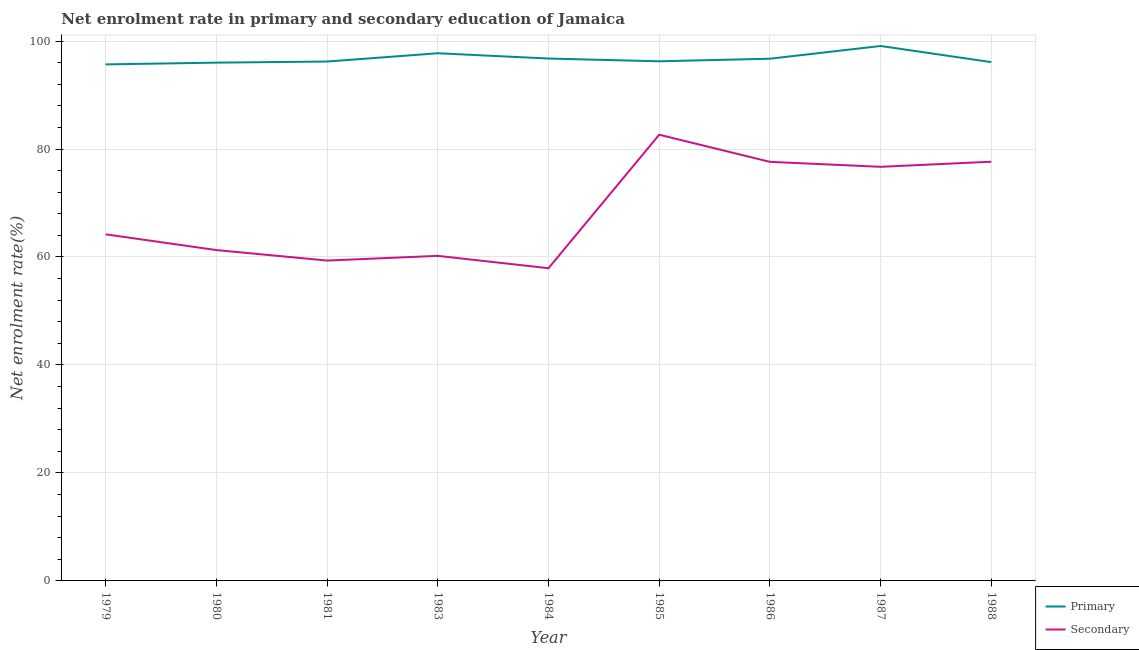How many different coloured lines are there?
Offer a very short reply. 2. What is the enrollment rate in primary education in 1979?
Provide a short and direct response. 95.67. Across all years, what is the maximum enrollment rate in secondary education?
Offer a very short reply. 82.65. Across all years, what is the minimum enrollment rate in primary education?
Keep it short and to the point. 95.67. In which year was the enrollment rate in primary education maximum?
Your answer should be very brief. 1987. In which year was the enrollment rate in primary education minimum?
Ensure brevity in your answer.  1979. What is the total enrollment rate in secondary education in the graph?
Your answer should be very brief. 617.58. What is the difference between the enrollment rate in primary education in 1985 and that in 1986?
Your answer should be compact. -0.48. What is the difference between the enrollment rate in secondary education in 1980 and the enrollment rate in primary education in 1988?
Offer a terse response. -34.81. What is the average enrollment rate in secondary education per year?
Give a very brief answer. 68.62. In the year 1987, what is the difference between the enrollment rate in secondary education and enrollment rate in primary education?
Make the answer very short. -22.38. What is the ratio of the enrollment rate in secondary education in 1981 to that in 1986?
Your answer should be very brief. 0.76. What is the difference between the highest and the second highest enrollment rate in secondary education?
Keep it short and to the point. 5. What is the difference between the highest and the lowest enrollment rate in primary education?
Provide a short and direct response. 3.41. Is the sum of the enrollment rate in secondary education in 1983 and 1985 greater than the maximum enrollment rate in primary education across all years?
Give a very brief answer. Yes. Is the enrollment rate in secondary education strictly less than the enrollment rate in primary education over the years?
Provide a short and direct response. Yes. What is the difference between two consecutive major ticks on the Y-axis?
Your answer should be very brief. 20. Does the graph contain grids?
Your response must be concise. Yes. Where does the legend appear in the graph?
Give a very brief answer. Bottom right. What is the title of the graph?
Provide a succinct answer. Net enrolment rate in primary and secondary education of Jamaica. Does "Largest city" appear as one of the legend labels in the graph?
Provide a short and direct response. No. What is the label or title of the Y-axis?
Ensure brevity in your answer.  Net enrolment rate(%). What is the Net enrolment rate(%) in Primary in 1979?
Ensure brevity in your answer.  95.67. What is the Net enrolment rate(%) in Secondary in 1979?
Provide a short and direct response. 64.2. What is the Net enrolment rate(%) in Primary in 1980?
Offer a terse response. 96. What is the Net enrolment rate(%) of Secondary in 1980?
Offer a terse response. 61.28. What is the Net enrolment rate(%) in Primary in 1981?
Your answer should be compact. 96.2. What is the Net enrolment rate(%) of Secondary in 1981?
Your response must be concise. 59.34. What is the Net enrolment rate(%) in Primary in 1983?
Your answer should be very brief. 97.74. What is the Net enrolment rate(%) in Secondary in 1983?
Your answer should be very brief. 60.21. What is the Net enrolment rate(%) of Primary in 1984?
Your answer should be very brief. 96.76. What is the Net enrolment rate(%) of Secondary in 1984?
Provide a succinct answer. 57.92. What is the Net enrolment rate(%) in Primary in 1985?
Offer a very short reply. 96.25. What is the Net enrolment rate(%) of Secondary in 1985?
Keep it short and to the point. 82.65. What is the Net enrolment rate(%) of Primary in 1986?
Offer a terse response. 96.73. What is the Net enrolment rate(%) of Secondary in 1986?
Your answer should be very brief. 77.62. What is the Net enrolment rate(%) in Primary in 1987?
Make the answer very short. 99.08. What is the Net enrolment rate(%) in Secondary in 1987?
Your answer should be compact. 76.7. What is the Net enrolment rate(%) in Primary in 1988?
Provide a succinct answer. 96.09. What is the Net enrolment rate(%) in Secondary in 1988?
Ensure brevity in your answer.  77.65. Across all years, what is the maximum Net enrolment rate(%) of Primary?
Make the answer very short. 99.08. Across all years, what is the maximum Net enrolment rate(%) of Secondary?
Your response must be concise. 82.65. Across all years, what is the minimum Net enrolment rate(%) of Primary?
Make the answer very short. 95.67. Across all years, what is the minimum Net enrolment rate(%) in Secondary?
Make the answer very short. 57.92. What is the total Net enrolment rate(%) in Primary in the graph?
Your answer should be very brief. 870.53. What is the total Net enrolment rate(%) of Secondary in the graph?
Provide a short and direct response. 617.58. What is the difference between the Net enrolment rate(%) in Primary in 1979 and that in 1980?
Give a very brief answer. -0.32. What is the difference between the Net enrolment rate(%) in Secondary in 1979 and that in 1980?
Offer a terse response. 2.91. What is the difference between the Net enrolment rate(%) of Primary in 1979 and that in 1981?
Provide a short and direct response. -0.53. What is the difference between the Net enrolment rate(%) in Secondary in 1979 and that in 1981?
Keep it short and to the point. 4.86. What is the difference between the Net enrolment rate(%) in Primary in 1979 and that in 1983?
Provide a short and direct response. -2.07. What is the difference between the Net enrolment rate(%) in Secondary in 1979 and that in 1983?
Your response must be concise. 3.99. What is the difference between the Net enrolment rate(%) of Primary in 1979 and that in 1984?
Offer a very short reply. -1.09. What is the difference between the Net enrolment rate(%) in Secondary in 1979 and that in 1984?
Provide a short and direct response. 6.28. What is the difference between the Net enrolment rate(%) in Primary in 1979 and that in 1985?
Your response must be concise. -0.57. What is the difference between the Net enrolment rate(%) in Secondary in 1979 and that in 1985?
Your answer should be very brief. -18.45. What is the difference between the Net enrolment rate(%) in Primary in 1979 and that in 1986?
Offer a terse response. -1.05. What is the difference between the Net enrolment rate(%) in Secondary in 1979 and that in 1986?
Offer a very short reply. -13.43. What is the difference between the Net enrolment rate(%) of Primary in 1979 and that in 1987?
Ensure brevity in your answer.  -3.41. What is the difference between the Net enrolment rate(%) in Secondary in 1979 and that in 1987?
Your response must be concise. -12.51. What is the difference between the Net enrolment rate(%) in Primary in 1979 and that in 1988?
Your answer should be very brief. -0.42. What is the difference between the Net enrolment rate(%) in Secondary in 1979 and that in 1988?
Ensure brevity in your answer.  -13.45. What is the difference between the Net enrolment rate(%) in Primary in 1980 and that in 1981?
Give a very brief answer. -0.21. What is the difference between the Net enrolment rate(%) in Secondary in 1980 and that in 1981?
Your response must be concise. 1.94. What is the difference between the Net enrolment rate(%) in Primary in 1980 and that in 1983?
Your answer should be compact. -1.74. What is the difference between the Net enrolment rate(%) in Secondary in 1980 and that in 1983?
Give a very brief answer. 1.07. What is the difference between the Net enrolment rate(%) in Primary in 1980 and that in 1984?
Your response must be concise. -0.76. What is the difference between the Net enrolment rate(%) in Secondary in 1980 and that in 1984?
Make the answer very short. 3.36. What is the difference between the Net enrolment rate(%) of Primary in 1980 and that in 1985?
Offer a terse response. -0.25. What is the difference between the Net enrolment rate(%) in Secondary in 1980 and that in 1985?
Your answer should be very brief. -21.36. What is the difference between the Net enrolment rate(%) of Primary in 1980 and that in 1986?
Your answer should be very brief. -0.73. What is the difference between the Net enrolment rate(%) in Secondary in 1980 and that in 1986?
Your response must be concise. -16.34. What is the difference between the Net enrolment rate(%) of Primary in 1980 and that in 1987?
Keep it short and to the point. -3.09. What is the difference between the Net enrolment rate(%) in Secondary in 1980 and that in 1987?
Your answer should be compact. -15.42. What is the difference between the Net enrolment rate(%) in Primary in 1980 and that in 1988?
Offer a very short reply. -0.1. What is the difference between the Net enrolment rate(%) in Secondary in 1980 and that in 1988?
Provide a succinct answer. -16.37. What is the difference between the Net enrolment rate(%) of Primary in 1981 and that in 1983?
Give a very brief answer. -1.54. What is the difference between the Net enrolment rate(%) of Secondary in 1981 and that in 1983?
Your answer should be very brief. -0.87. What is the difference between the Net enrolment rate(%) in Primary in 1981 and that in 1984?
Offer a terse response. -0.56. What is the difference between the Net enrolment rate(%) of Secondary in 1981 and that in 1984?
Give a very brief answer. 1.42. What is the difference between the Net enrolment rate(%) in Primary in 1981 and that in 1985?
Offer a very short reply. -0.05. What is the difference between the Net enrolment rate(%) of Secondary in 1981 and that in 1985?
Provide a succinct answer. -23.31. What is the difference between the Net enrolment rate(%) in Primary in 1981 and that in 1986?
Your answer should be compact. -0.52. What is the difference between the Net enrolment rate(%) of Secondary in 1981 and that in 1986?
Offer a very short reply. -18.28. What is the difference between the Net enrolment rate(%) in Primary in 1981 and that in 1987?
Provide a short and direct response. -2.88. What is the difference between the Net enrolment rate(%) in Secondary in 1981 and that in 1987?
Provide a short and direct response. -17.36. What is the difference between the Net enrolment rate(%) of Primary in 1981 and that in 1988?
Offer a very short reply. 0.11. What is the difference between the Net enrolment rate(%) in Secondary in 1981 and that in 1988?
Ensure brevity in your answer.  -18.31. What is the difference between the Net enrolment rate(%) in Primary in 1983 and that in 1984?
Ensure brevity in your answer.  0.98. What is the difference between the Net enrolment rate(%) in Secondary in 1983 and that in 1984?
Your answer should be compact. 2.29. What is the difference between the Net enrolment rate(%) of Primary in 1983 and that in 1985?
Ensure brevity in your answer.  1.49. What is the difference between the Net enrolment rate(%) of Secondary in 1983 and that in 1985?
Your answer should be compact. -22.44. What is the difference between the Net enrolment rate(%) in Primary in 1983 and that in 1986?
Give a very brief answer. 1.01. What is the difference between the Net enrolment rate(%) of Secondary in 1983 and that in 1986?
Keep it short and to the point. -17.41. What is the difference between the Net enrolment rate(%) in Primary in 1983 and that in 1987?
Provide a short and direct response. -1.34. What is the difference between the Net enrolment rate(%) of Secondary in 1983 and that in 1987?
Your answer should be very brief. -16.49. What is the difference between the Net enrolment rate(%) in Primary in 1983 and that in 1988?
Provide a succinct answer. 1.64. What is the difference between the Net enrolment rate(%) of Secondary in 1983 and that in 1988?
Give a very brief answer. -17.44. What is the difference between the Net enrolment rate(%) in Primary in 1984 and that in 1985?
Offer a terse response. 0.51. What is the difference between the Net enrolment rate(%) in Secondary in 1984 and that in 1985?
Make the answer very short. -24.72. What is the difference between the Net enrolment rate(%) in Primary in 1984 and that in 1986?
Your response must be concise. 0.03. What is the difference between the Net enrolment rate(%) of Secondary in 1984 and that in 1986?
Offer a terse response. -19.7. What is the difference between the Net enrolment rate(%) in Primary in 1984 and that in 1987?
Offer a terse response. -2.32. What is the difference between the Net enrolment rate(%) of Secondary in 1984 and that in 1987?
Keep it short and to the point. -18.78. What is the difference between the Net enrolment rate(%) of Primary in 1984 and that in 1988?
Your response must be concise. 0.67. What is the difference between the Net enrolment rate(%) in Secondary in 1984 and that in 1988?
Provide a succinct answer. -19.73. What is the difference between the Net enrolment rate(%) in Primary in 1985 and that in 1986?
Make the answer very short. -0.48. What is the difference between the Net enrolment rate(%) in Secondary in 1985 and that in 1986?
Keep it short and to the point. 5.02. What is the difference between the Net enrolment rate(%) in Primary in 1985 and that in 1987?
Your answer should be compact. -2.83. What is the difference between the Net enrolment rate(%) in Secondary in 1985 and that in 1987?
Your response must be concise. 5.94. What is the difference between the Net enrolment rate(%) of Primary in 1985 and that in 1988?
Your answer should be very brief. 0.15. What is the difference between the Net enrolment rate(%) of Secondary in 1985 and that in 1988?
Ensure brevity in your answer.  5. What is the difference between the Net enrolment rate(%) of Primary in 1986 and that in 1987?
Keep it short and to the point. -2.36. What is the difference between the Net enrolment rate(%) in Secondary in 1986 and that in 1987?
Offer a terse response. 0.92. What is the difference between the Net enrolment rate(%) of Primary in 1986 and that in 1988?
Offer a very short reply. 0.63. What is the difference between the Net enrolment rate(%) in Secondary in 1986 and that in 1988?
Give a very brief answer. -0.03. What is the difference between the Net enrolment rate(%) in Primary in 1987 and that in 1988?
Ensure brevity in your answer.  2.99. What is the difference between the Net enrolment rate(%) of Secondary in 1987 and that in 1988?
Your answer should be compact. -0.95. What is the difference between the Net enrolment rate(%) of Primary in 1979 and the Net enrolment rate(%) of Secondary in 1980?
Ensure brevity in your answer.  34.39. What is the difference between the Net enrolment rate(%) of Primary in 1979 and the Net enrolment rate(%) of Secondary in 1981?
Your answer should be compact. 36.33. What is the difference between the Net enrolment rate(%) in Primary in 1979 and the Net enrolment rate(%) in Secondary in 1983?
Provide a short and direct response. 35.46. What is the difference between the Net enrolment rate(%) of Primary in 1979 and the Net enrolment rate(%) of Secondary in 1984?
Offer a terse response. 37.75. What is the difference between the Net enrolment rate(%) of Primary in 1979 and the Net enrolment rate(%) of Secondary in 1985?
Ensure brevity in your answer.  13.03. What is the difference between the Net enrolment rate(%) of Primary in 1979 and the Net enrolment rate(%) of Secondary in 1986?
Ensure brevity in your answer.  18.05. What is the difference between the Net enrolment rate(%) in Primary in 1979 and the Net enrolment rate(%) in Secondary in 1987?
Provide a short and direct response. 18.97. What is the difference between the Net enrolment rate(%) of Primary in 1979 and the Net enrolment rate(%) of Secondary in 1988?
Your response must be concise. 18.02. What is the difference between the Net enrolment rate(%) of Primary in 1980 and the Net enrolment rate(%) of Secondary in 1981?
Give a very brief answer. 36.66. What is the difference between the Net enrolment rate(%) in Primary in 1980 and the Net enrolment rate(%) in Secondary in 1983?
Give a very brief answer. 35.79. What is the difference between the Net enrolment rate(%) in Primary in 1980 and the Net enrolment rate(%) in Secondary in 1984?
Provide a short and direct response. 38.08. What is the difference between the Net enrolment rate(%) in Primary in 1980 and the Net enrolment rate(%) in Secondary in 1985?
Your answer should be compact. 13.35. What is the difference between the Net enrolment rate(%) of Primary in 1980 and the Net enrolment rate(%) of Secondary in 1986?
Offer a very short reply. 18.37. What is the difference between the Net enrolment rate(%) of Primary in 1980 and the Net enrolment rate(%) of Secondary in 1987?
Offer a very short reply. 19.29. What is the difference between the Net enrolment rate(%) of Primary in 1980 and the Net enrolment rate(%) of Secondary in 1988?
Offer a very short reply. 18.35. What is the difference between the Net enrolment rate(%) in Primary in 1981 and the Net enrolment rate(%) in Secondary in 1983?
Give a very brief answer. 35.99. What is the difference between the Net enrolment rate(%) in Primary in 1981 and the Net enrolment rate(%) in Secondary in 1984?
Your answer should be compact. 38.28. What is the difference between the Net enrolment rate(%) in Primary in 1981 and the Net enrolment rate(%) in Secondary in 1985?
Ensure brevity in your answer.  13.56. What is the difference between the Net enrolment rate(%) of Primary in 1981 and the Net enrolment rate(%) of Secondary in 1986?
Provide a short and direct response. 18.58. What is the difference between the Net enrolment rate(%) in Primary in 1981 and the Net enrolment rate(%) in Secondary in 1987?
Offer a very short reply. 19.5. What is the difference between the Net enrolment rate(%) of Primary in 1981 and the Net enrolment rate(%) of Secondary in 1988?
Your answer should be very brief. 18.55. What is the difference between the Net enrolment rate(%) in Primary in 1983 and the Net enrolment rate(%) in Secondary in 1984?
Your answer should be compact. 39.82. What is the difference between the Net enrolment rate(%) in Primary in 1983 and the Net enrolment rate(%) in Secondary in 1985?
Ensure brevity in your answer.  15.09. What is the difference between the Net enrolment rate(%) of Primary in 1983 and the Net enrolment rate(%) of Secondary in 1986?
Provide a succinct answer. 20.12. What is the difference between the Net enrolment rate(%) in Primary in 1983 and the Net enrolment rate(%) in Secondary in 1987?
Ensure brevity in your answer.  21.04. What is the difference between the Net enrolment rate(%) of Primary in 1983 and the Net enrolment rate(%) of Secondary in 1988?
Keep it short and to the point. 20.09. What is the difference between the Net enrolment rate(%) in Primary in 1984 and the Net enrolment rate(%) in Secondary in 1985?
Your answer should be very brief. 14.11. What is the difference between the Net enrolment rate(%) of Primary in 1984 and the Net enrolment rate(%) of Secondary in 1986?
Your response must be concise. 19.14. What is the difference between the Net enrolment rate(%) of Primary in 1984 and the Net enrolment rate(%) of Secondary in 1987?
Provide a short and direct response. 20.06. What is the difference between the Net enrolment rate(%) of Primary in 1984 and the Net enrolment rate(%) of Secondary in 1988?
Give a very brief answer. 19.11. What is the difference between the Net enrolment rate(%) of Primary in 1985 and the Net enrolment rate(%) of Secondary in 1986?
Offer a very short reply. 18.63. What is the difference between the Net enrolment rate(%) of Primary in 1985 and the Net enrolment rate(%) of Secondary in 1987?
Your answer should be compact. 19.55. What is the difference between the Net enrolment rate(%) in Primary in 1985 and the Net enrolment rate(%) in Secondary in 1988?
Your response must be concise. 18.6. What is the difference between the Net enrolment rate(%) in Primary in 1986 and the Net enrolment rate(%) in Secondary in 1987?
Provide a short and direct response. 20.02. What is the difference between the Net enrolment rate(%) in Primary in 1986 and the Net enrolment rate(%) in Secondary in 1988?
Your answer should be very brief. 19.08. What is the difference between the Net enrolment rate(%) of Primary in 1987 and the Net enrolment rate(%) of Secondary in 1988?
Offer a terse response. 21.43. What is the average Net enrolment rate(%) of Primary per year?
Give a very brief answer. 96.73. What is the average Net enrolment rate(%) in Secondary per year?
Ensure brevity in your answer.  68.62. In the year 1979, what is the difference between the Net enrolment rate(%) of Primary and Net enrolment rate(%) of Secondary?
Offer a very short reply. 31.48. In the year 1980, what is the difference between the Net enrolment rate(%) of Primary and Net enrolment rate(%) of Secondary?
Your response must be concise. 34.71. In the year 1981, what is the difference between the Net enrolment rate(%) in Primary and Net enrolment rate(%) in Secondary?
Provide a short and direct response. 36.86. In the year 1983, what is the difference between the Net enrolment rate(%) of Primary and Net enrolment rate(%) of Secondary?
Keep it short and to the point. 37.53. In the year 1984, what is the difference between the Net enrolment rate(%) of Primary and Net enrolment rate(%) of Secondary?
Provide a short and direct response. 38.84. In the year 1985, what is the difference between the Net enrolment rate(%) of Primary and Net enrolment rate(%) of Secondary?
Ensure brevity in your answer.  13.6. In the year 1986, what is the difference between the Net enrolment rate(%) in Primary and Net enrolment rate(%) in Secondary?
Offer a very short reply. 19.1. In the year 1987, what is the difference between the Net enrolment rate(%) in Primary and Net enrolment rate(%) in Secondary?
Ensure brevity in your answer.  22.38. In the year 1988, what is the difference between the Net enrolment rate(%) in Primary and Net enrolment rate(%) in Secondary?
Make the answer very short. 18.44. What is the ratio of the Net enrolment rate(%) of Primary in 1979 to that in 1980?
Ensure brevity in your answer.  1. What is the ratio of the Net enrolment rate(%) of Secondary in 1979 to that in 1980?
Ensure brevity in your answer.  1.05. What is the ratio of the Net enrolment rate(%) in Primary in 1979 to that in 1981?
Make the answer very short. 0.99. What is the ratio of the Net enrolment rate(%) of Secondary in 1979 to that in 1981?
Your answer should be compact. 1.08. What is the ratio of the Net enrolment rate(%) of Primary in 1979 to that in 1983?
Keep it short and to the point. 0.98. What is the ratio of the Net enrolment rate(%) in Secondary in 1979 to that in 1983?
Give a very brief answer. 1.07. What is the ratio of the Net enrolment rate(%) in Secondary in 1979 to that in 1984?
Your response must be concise. 1.11. What is the ratio of the Net enrolment rate(%) of Secondary in 1979 to that in 1985?
Provide a succinct answer. 0.78. What is the ratio of the Net enrolment rate(%) of Primary in 1979 to that in 1986?
Offer a very short reply. 0.99. What is the ratio of the Net enrolment rate(%) in Secondary in 1979 to that in 1986?
Give a very brief answer. 0.83. What is the ratio of the Net enrolment rate(%) of Primary in 1979 to that in 1987?
Ensure brevity in your answer.  0.97. What is the ratio of the Net enrolment rate(%) of Secondary in 1979 to that in 1987?
Offer a very short reply. 0.84. What is the ratio of the Net enrolment rate(%) of Primary in 1979 to that in 1988?
Your answer should be very brief. 1. What is the ratio of the Net enrolment rate(%) of Secondary in 1979 to that in 1988?
Your answer should be very brief. 0.83. What is the ratio of the Net enrolment rate(%) of Primary in 1980 to that in 1981?
Offer a very short reply. 1. What is the ratio of the Net enrolment rate(%) in Secondary in 1980 to that in 1981?
Keep it short and to the point. 1.03. What is the ratio of the Net enrolment rate(%) in Primary in 1980 to that in 1983?
Provide a short and direct response. 0.98. What is the ratio of the Net enrolment rate(%) in Secondary in 1980 to that in 1983?
Give a very brief answer. 1.02. What is the ratio of the Net enrolment rate(%) of Primary in 1980 to that in 1984?
Your answer should be compact. 0.99. What is the ratio of the Net enrolment rate(%) of Secondary in 1980 to that in 1984?
Ensure brevity in your answer.  1.06. What is the ratio of the Net enrolment rate(%) of Secondary in 1980 to that in 1985?
Offer a very short reply. 0.74. What is the ratio of the Net enrolment rate(%) in Secondary in 1980 to that in 1986?
Offer a terse response. 0.79. What is the ratio of the Net enrolment rate(%) of Primary in 1980 to that in 1987?
Offer a terse response. 0.97. What is the ratio of the Net enrolment rate(%) of Secondary in 1980 to that in 1987?
Your answer should be very brief. 0.8. What is the ratio of the Net enrolment rate(%) of Primary in 1980 to that in 1988?
Ensure brevity in your answer.  1. What is the ratio of the Net enrolment rate(%) of Secondary in 1980 to that in 1988?
Ensure brevity in your answer.  0.79. What is the ratio of the Net enrolment rate(%) of Primary in 1981 to that in 1983?
Your response must be concise. 0.98. What is the ratio of the Net enrolment rate(%) in Secondary in 1981 to that in 1983?
Give a very brief answer. 0.99. What is the ratio of the Net enrolment rate(%) of Secondary in 1981 to that in 1984?
Keep it short and to the point. 1.02. What is the ratio of the Net enrolment rate(%) in Secondary in 1981 to that in 1985?
Your response must be concise. 0.72. What is the ratio of the Net enrolment rate(%) of Secondary in 1981 to that in 1986?
Provide a succinct answer. 0.76. What is the ratio of the Net enrolment rate(%) of Primary in 1981 to that in 1987?
Give a very brief answer. 0.97. What is the ratio of the Net enrolment rate(%) in Secondary in 1981 to that in 1987?
Give a very brief answer. 0.77. What is the ratio of the Net enrolment rate(%) of Primary in 1981 to that in 1988?
Offer a very short reply. 1. What is the ratio of the Net enrolment rate(%) in Secondary in 1981 to that in 1988?
Provide a succinct answer. 0.76. What is the ratio of the Net enrolment rate(%) in Secondary in 1983 to that in 1984?
Offer a terse response. 1.04. What is the ratio of the Net enrolment rate(%) in Primary in 1983 to that in 1985?
Offer a very short reply. 1.02. What is the ratio of the Net enrolment rate(%) of Secondary in 1983 to that in 1985?
Provide a succinct answer. 0.73. What is the ratio of the Net enrolment rate(%) in Primary in 1983 to that in 1986?
Offer a terse response. 1.01. What is the ratio of the Net enrolment rate(%) of Secondary in 1983 to that in 1986?
Your answer should be compact. 0.78. What is the ratio of the Net enrolment rate(%) of Primary in 1983 to that in 1987?
Your response must be concise. 0.99. What is the ratio of the Net enrolment rate(%) in Secondary in 1983 to that in 1987?
Make the answer very short. 0.79. What is the ratio of the Net enrolment rate(%) in Primary in 1983 to that in 1988?
Your answer should be compact. 1.02. What is the ratio of the Net enrolment rate(%) in Secondary in 1983 to that in 1988?
Your response must be concise. 0.78. What is the ratio of the Net enrolment rate(%) of Secondary in 1984 to that in 1985?
Provide a short and direct response. 0.7. What is the ratio of the Net enrolment rate(%) of Primary in 1984 to that in 1986?
Keep it short and to the point. 1. What is the ratio of the Net enrolment rate(%) in Secondary in 1984 to that in 1986?
Make the answer very short. 0.75. What is the ratio of the Net enrolment rate(%) in Primary in 1984 to that in 1987?
Keep it short and to the point. 0.98. What is the ratio of the Net enrolment rate(%) of Secondary in 1984 to that in 1987?
Make the answer very short. 0.76. What is the ratio of the Net enrolment rate(%) in Secondary in 1984 to that in 1988?
Provide a succinct answer. 0.75. What is the ratio of the Net enrolment rate(%) in Secondary in 1985 to that in 1986?
Provide a short and direct response. 1.06. What is the ratio of the Net enrolment rate(%) of Primary in 1985 to that in 1987?
Offer a terse response. 0.97. What is the ratio of the Net enrolment rate(%) in Secondary in 1985 to that in 1987?
Your answer should be very brief. 1.08. What is the ratio of the Net enrolment rate(%) of Secondary in 1985 to that in 1988?
Ensure brevity in your answer.  1.06. What is the ratio of the Net enrolment rate(%) in Primary in 1986 to that in 1987?
Offer a very short reply. 0.98. What is the ratio of the Net enrolment rate(%) of Secondary in 1986 to that in 1987?
Your response must be concise. 1.01. What is the ratio of the Net enrolment rate(%) in Primary in 1986 to that in 1988?
Make the answer very short. 1.01. What is the ratio of the Net enrolment rate(%) of Primary in 1987 to that in 1988?
Provide a succinct answer. 1.03. What is the ratio of the Net enrolment rate(%) of Secondary in 1987 to that in 1988?
Your answer should be compact. 0.99. What is the difference between the highest and the second highest Net enrolment rate(%) of Primary?
Your response must be concise. 1.34. What is the difference between the highest and the second highest Net enrolment rate(%) in Secondary?
Make the answer very short. 5. What is the difference between the highest and the lowest Net enrolment rate(%) in Primary?
Ensure brevity in your answer.  3.41. What is the difference between the highest and the lowest Net enrolment rate(%) of Secondary?
Give a very brief answer. 24.72. 